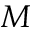<formula> <loc_0><loc_0><loc_500><loc_500>M</formula> 